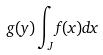Convert formula to latex. <formula><loc_0><loc_0><loc_500><loc_500>g ( y ) \int _ { J } f ( x ) d x</formula> 